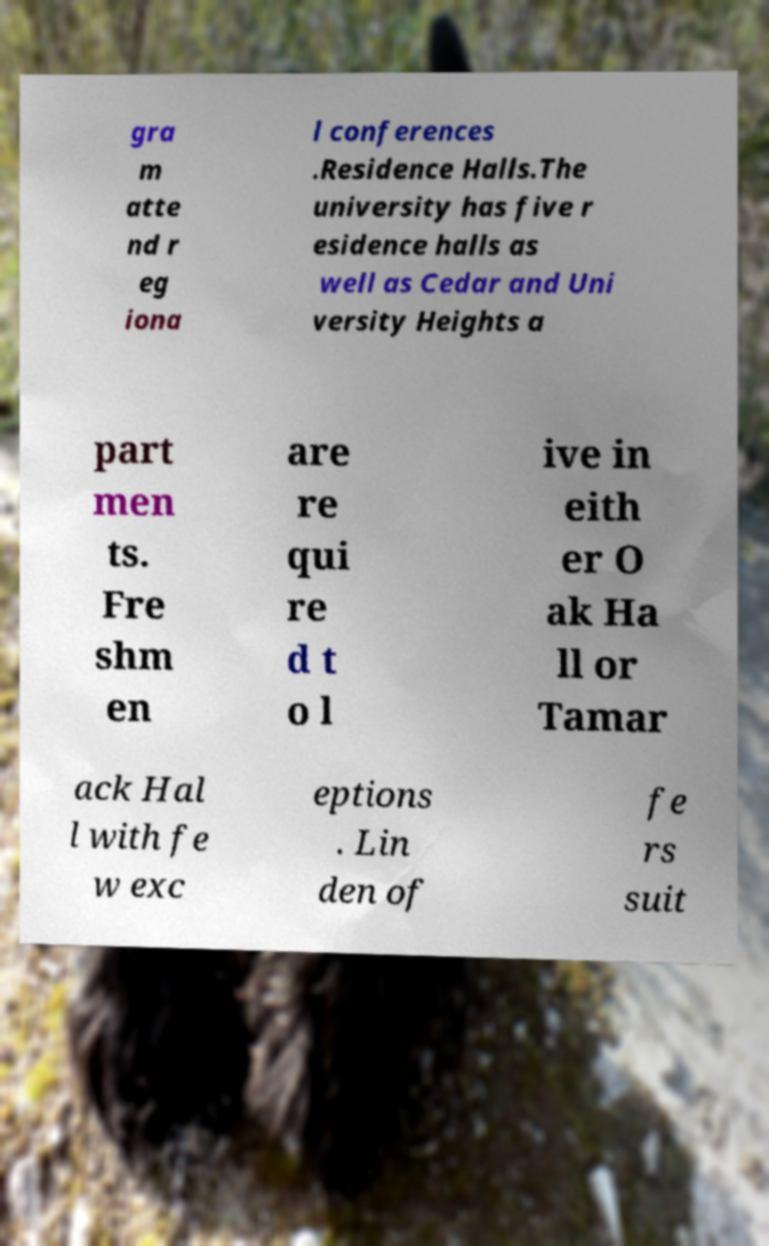For documentation purposes, I need the text within this image transcribed. Could you provide that? gra m atte nd r eg iona l conferences .Residence Halls.The university has five r esidence halls as well as Cedar and Uni versity Heights a part men ts. Fre shm en are re qui re d t o l ive in eith er O ak Ha ll or Tamar ack Hal l with fe w exc eptions . Lin den of fe rs suit 